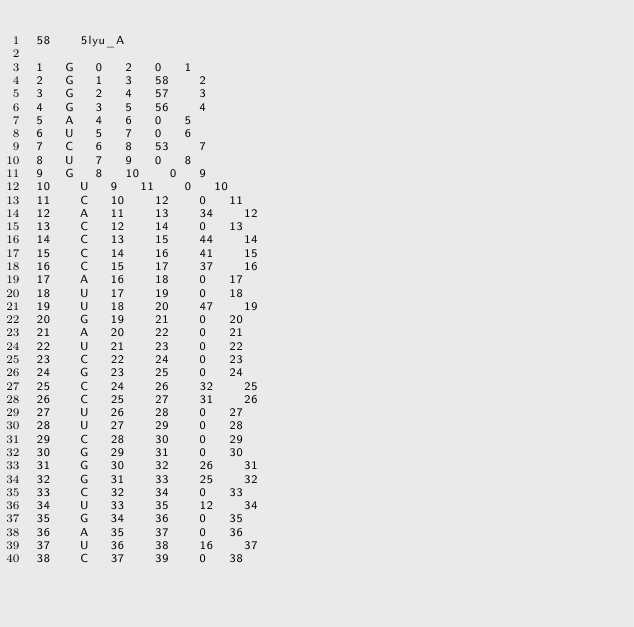<code> <loc_0><loc_0><loc_500><loc_500><_XML_>58		5lyu_A

1		G		0		2		0		1
2		G		1		3		58		2
3		G		2		4		57		3
4		G		3		5		56		4
5		A		4		6		0		5
6		U		5		7		0		6
7		C		6		8		53		7
8		U		7		9		0		8
9		G		8		10		0		9
10		U		9		11		0		10
11		C		10		12		0		11
12		A		11		13		34		12
13		C		12		14		0		13
14		C		13		15		44		14
15		C		14		16		41		15
16		C		15		17		37		16
17		A		16		18		0		17
18		U		17		19		0		18
19		U		18		20		47		19
20		G		19		21		0		20
21		A		20		22		0		21
22		U		21		23		0		22
23		C		22		24		0		23
24		G		23		25		0		24
25		C		24		26		32		25
26		C		25		27		31		26
27		U		26		28		0		27
28		U		27		29		0		28
29		C		28		30		0		29
30		G		29		31		0		30
31		G		30		32		26		31
32		G		31		33		25		32
33		C		32		34		0		33
34		U		33		35		12		34
35		G		34		36		0		35
36		A		35		37		0		36
37		U		36		38		16		37
38		C		37		39		0		38</code> 